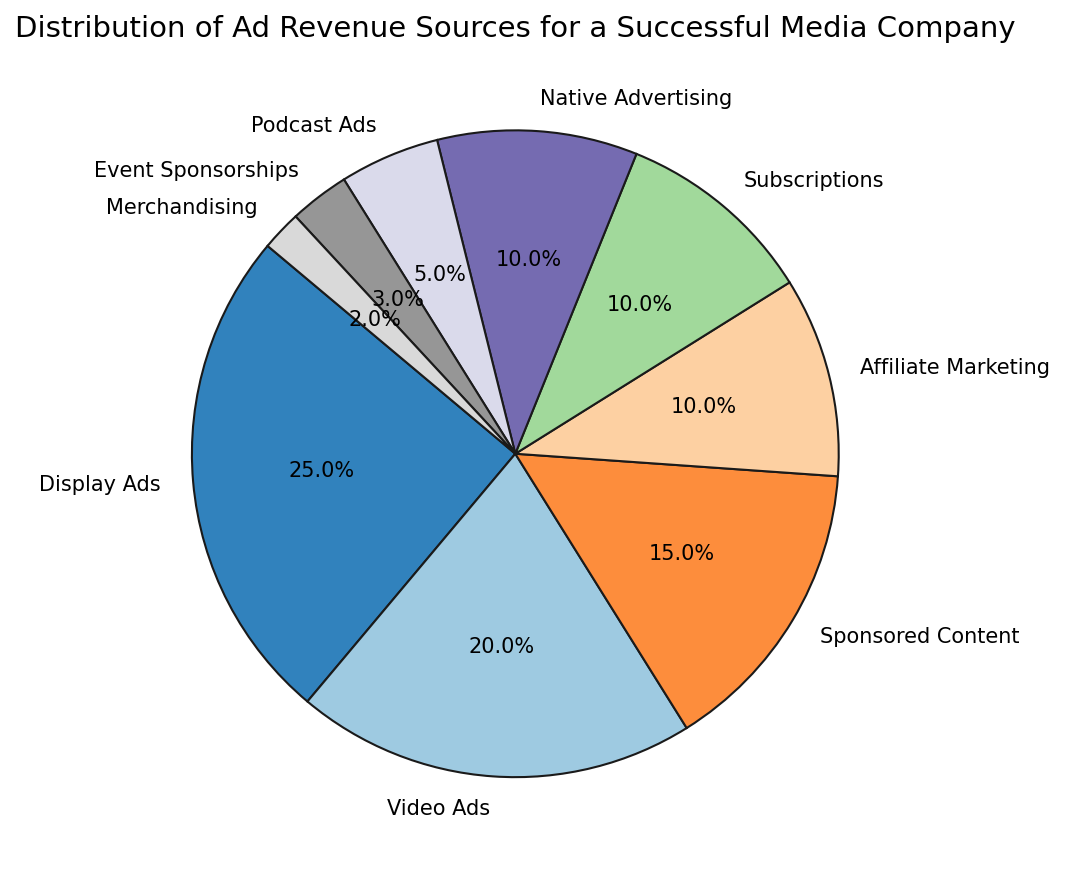What is the total percentage of all ad revenue sources related to video content (including Video Ads and Sponsored Content)? To solve this, add the percentages of Video Ads (20%) and Sponsored Content (15%). So, the total percentage is 20% + 15% = 35%.
Answer: 35% Which ad revenue source contributes the least to the overall revenue? The ad revenue sources and their percentages can be seen in the pie chart. The source with the smallest percentage is Merchandising at 2%.
Answer: Merchandising What is the combined percentage of Affiliate Marketing, Subscriptions, and Native Advertising? Combine the percentages of Affiliate Marketing (10%), Subscriptions (10%), and Native Advertising (10%). Adding them gives us 10% + 10% + 10% = 30%.
Answer: 30% Are Event Sponsorships contributing more revenue than Podcast Ads? From the pie chart, we see that Podcast Ads contribute 5% while Event Sponsorships contribute 3%. Hence, Podcast Ads contribute more.
Answer: No What percentage of the revenue comes from sources that contribute 10% each? Identify the sources with 10% each: Affiliate Marketing, Subscriptions, and Native Advertising. Adding these gives us 10% + 10% + 10% = 30%.
Answer: 30% Which ad revenue source is exactly half of Display Ads in percentage contribution? Display Ads contribute 25%. Half of this is 25% / 2 = 12.5%. None of the sources contribute exactly 12.5%, hence no source fits this criteria.
Answer: None If Display Ads and Video Ads are combined, what percentage of the total revenue do they make up? Add the percentages of Display Ads (25%) and Video Ads (20%). The combined contribution is 25% + 20% = 45%.
Answer: 45% Which ad revenue source is closest in percentage to Podcast Ads? Podcast Ads contribute 5%. The closest percentages are Event Sponsorships with 3% and Merchandising with 2%. Event Sponsorships are closer to 5%.
Answer: Event Sponsorships Does the combination of Event Sponsorships and Merchandising exceed the percentage contribution of Podcast Ads? Event Sponsorships contribute 3% and Merchandising contributes 2%. Their combined contribution is 3% + 2% = 5%, which is equal to the contribution of Podcast Ads.
Answer: No 